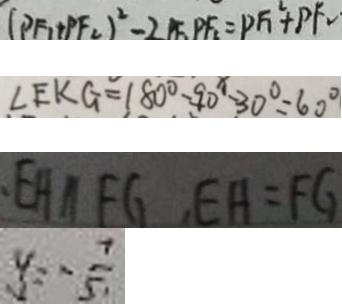<formula> <loc_0><loc_0><loc_500><loc_500>( P F _ { 1 } + P F _ { 2 } ) ^ { 2 } - 2 P F _ { 1 } P F _ { 2 } = P F _ { 1 } ^ { 2 } + P F _ { 2 } . 
 \angle E K G = 1 8 0 ^ { \circ } - 9 0 ^ { x } - 3 0 ^ { \circ } = 6 0 ^ { \circ } 
 E H / / F G , E H = F G 
 y = - \frac { 7 } { 5 }</formula> 